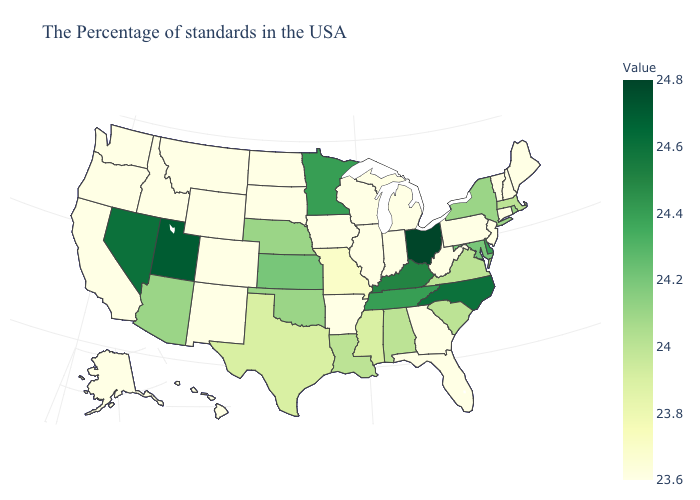Among the states that border New Mexico , does Arizona have the highest value?
Short answer required. No. Does Ohio have the highest value in the MidWest?
Short answer required. Yes. Is the legend a continuous bar?
Give a very brief answer. Yes. Does the map have missing data?
Answer briefly. No. Does Tennessee have the highest value in the USA?
Quick response, please. No. 